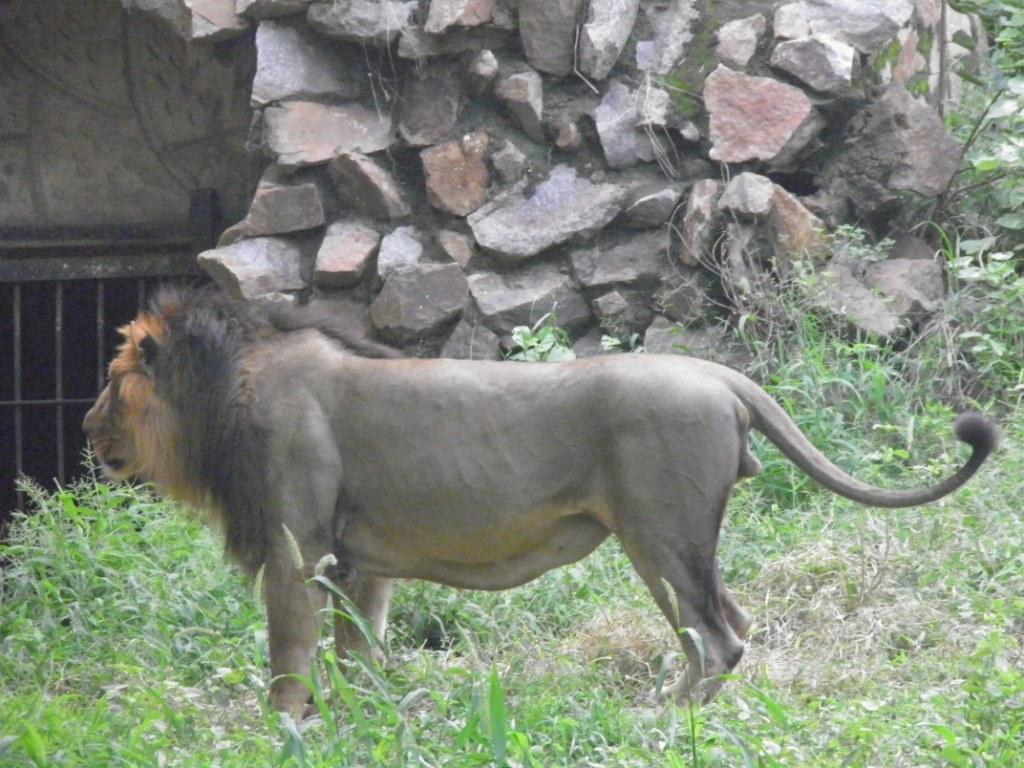What animal is in the picture? There is a lion in the picture. What is the lion doing in the picture? The lion is standing. What type of terrain is visible at the bottom of the picture? There is grass at the bottom of the picture. What can be seen in the background of the picture? There are rocks visible in the background of the picture. What type of ornament is hanging from the lion's neck in the picture? There is no ornament hanging from the lion's neck in the picture. Is there a party happening in the background of the picture? There is no party visible in the picture; it only shows a lion standing on grass with rocks in the background. 